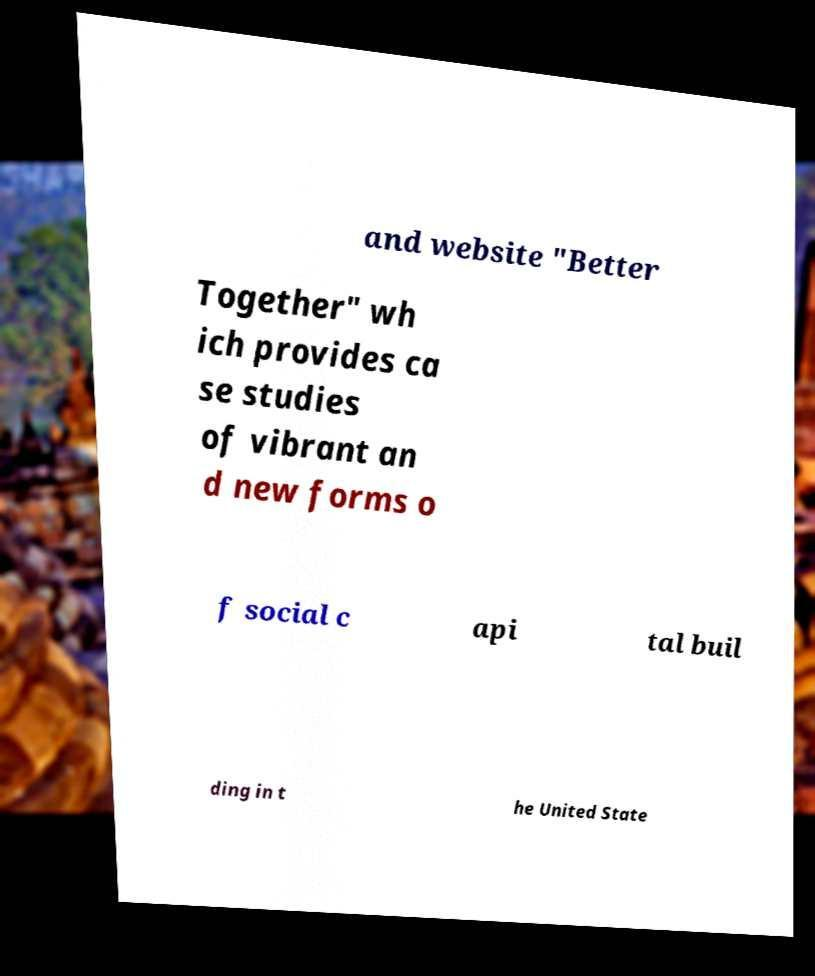Could you assist in decoding the text presented in this image and type it out clearly? and website "Better Together" wh ich provides ca se studies of vibrant an d new forms o f social c api tal buil ding in t he United State 